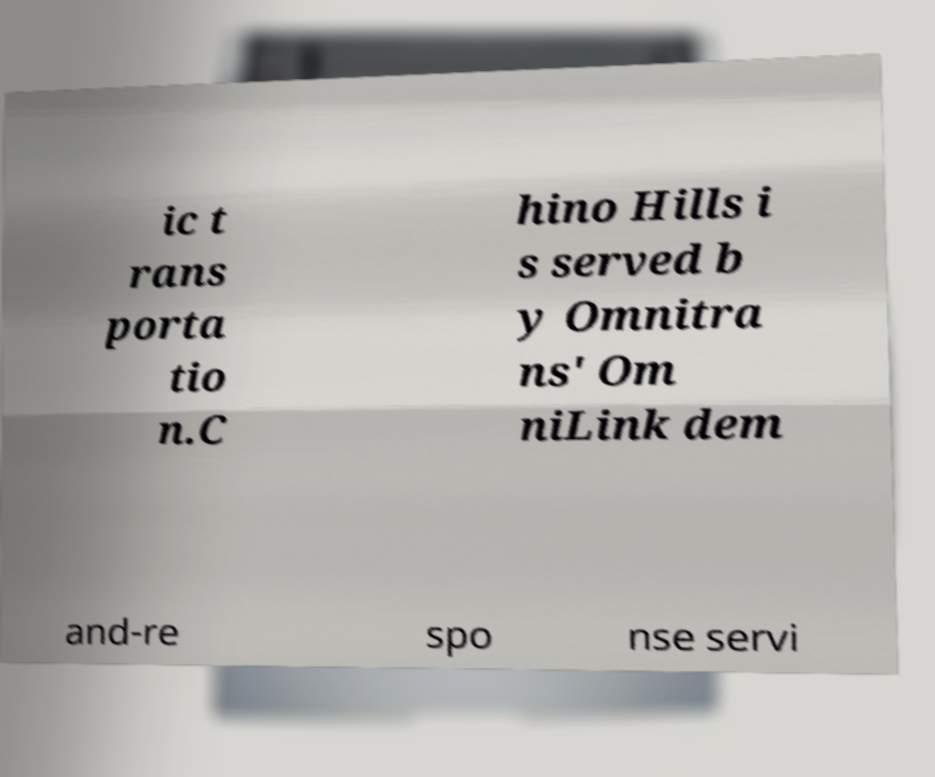Please read and relay the text visible in this image. What does it say? ic t rans porta tio n.C hino Hills i s served b y Omnitra ns' Om niLink dem and-re spo nse servi 